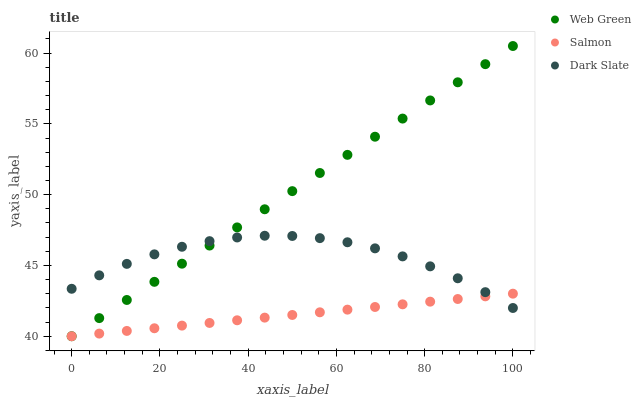Does Salmon have the minimum area under the curve?
Answer yes or no. Yes. Does Web Green have the maximum area under the curve?
Answer yes or no. Yes. Does Web Green have the minimum area under the curve?
Answer yes or no. No. Does Salmon have the maximum area under the curve?
Answer yes or no. No. Is Salmon the smoothest?
Answer yes or no. Yes. Is Dark Slate the roughest?
Answer yes or no. Yes. Is Web Green the smoothest?
Answer yes or no. No. Is Web Green the roughest?
Answer yes or no. No. Does Salmon have the lowest value?
Answer yes or no. Yes. Does Web Green have the highest value?
Answer yes or no. Yes. Does Salmon have the highest value?
Answer yes or no. No. Does Salmon intersect Dark Slate?
Answer yes or no. Yes. Is Salmon less than Dark Slate?
Answer yes or no. No. Is Salmon greater than Dark Slate?
Answer yes or no. No. 